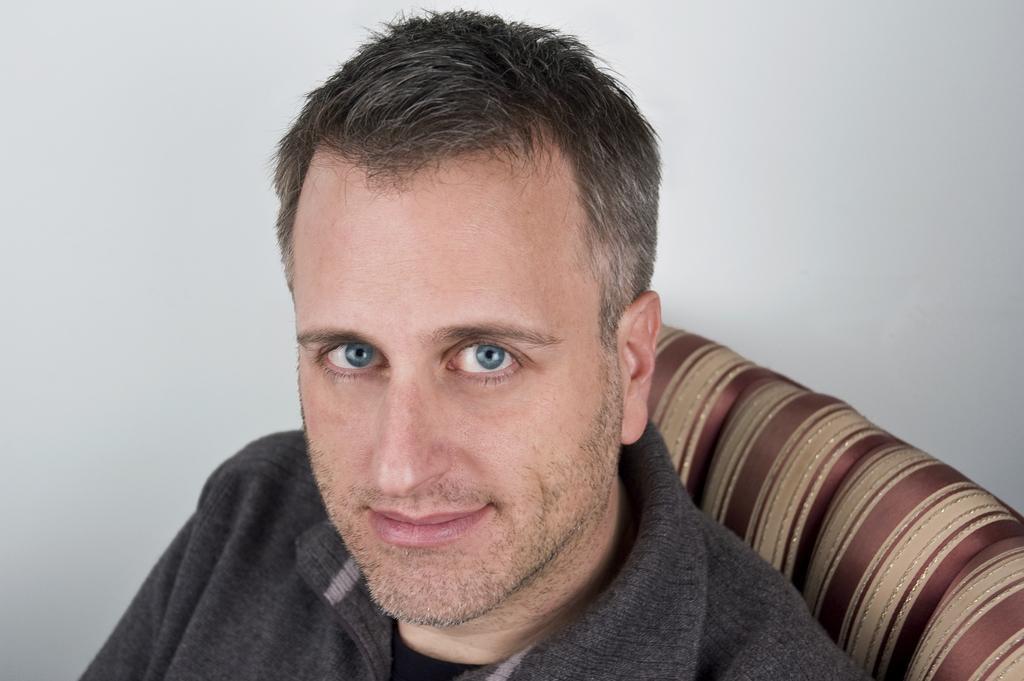Describe this image in one or two sentences. In this picture, we see a man in the black jacket is sitting on the chair or a sofa. He is smiling and he might be posing for the photo. In the background, it is white in color and it might be a white wall. 